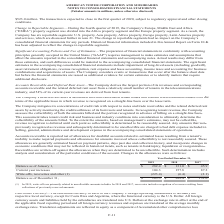According to American Tower Corporation's financial document, Where does the company derive the largest portion of its revenues and corresponding accounts receivable and the related deferred rent asset from? a relatively small number of tenants in the telecommunications industry, and 54% of its current-year revenues are derived from four tenants.. The document states: "eceivable and the related deferred rent asset from a relatively small number of tenants in the telecommunications industry, and 54% of its current-yea..." Also, In 2019, what were the write-offs primarily related to? uncollectible amounts in India. The document states: "(1) In 2019, write-offs are primarily related to uncollectible amounts in India. In 2018 and 2017, recoveries include recognition of revenue resulting..." Also, What was the balance as at January 1, 2019? According to the financial document, $282.4 (in millions). The relevant text states: "Balance as of January 1, $ 282.4 $ 131.0 $ 45.9..." Also, can you calculate: What was the change in balance as of January 1 between 2018 and 2019? Based on the calculation: $282.4-$131.0, the result is 151.4 (in millions). This is based on the information: "Balance as of January 1, $ 282.4 $ 131.0 $ 45.9 Balance as of January 1, $ 282.4 $ 131.0 $ 45.9..." The key data points involved are: 131.0, 282.4. Also, can you calculate: What was the change in current year increases between 2017 and 2018? Based on the calculation: 157.8-87.2, the result is 70.6 (in millions). This is based on the information: "Current year increases 104.3 157.8 87.2 Current year increases 104.3 157.8 87.2..." The key data points involved are: 157.8, 87.2. Also, can you calculate: What was the percentage change in balance as of December 31 between 2018 and 2019? To answer this question, I need to perform calculations using the financial data. The calculation is: ($163.3-$282.4)/$282.4, which equals -42.17 (percentage). This is based on the information: "Balance as of January 1, $ 282.4 $ 131.0 $ 45.9 Balance as of December 31, $ 163.3 $ 282.4 $ 131.0..." The key data points involved are: 163.3, 282.4. 